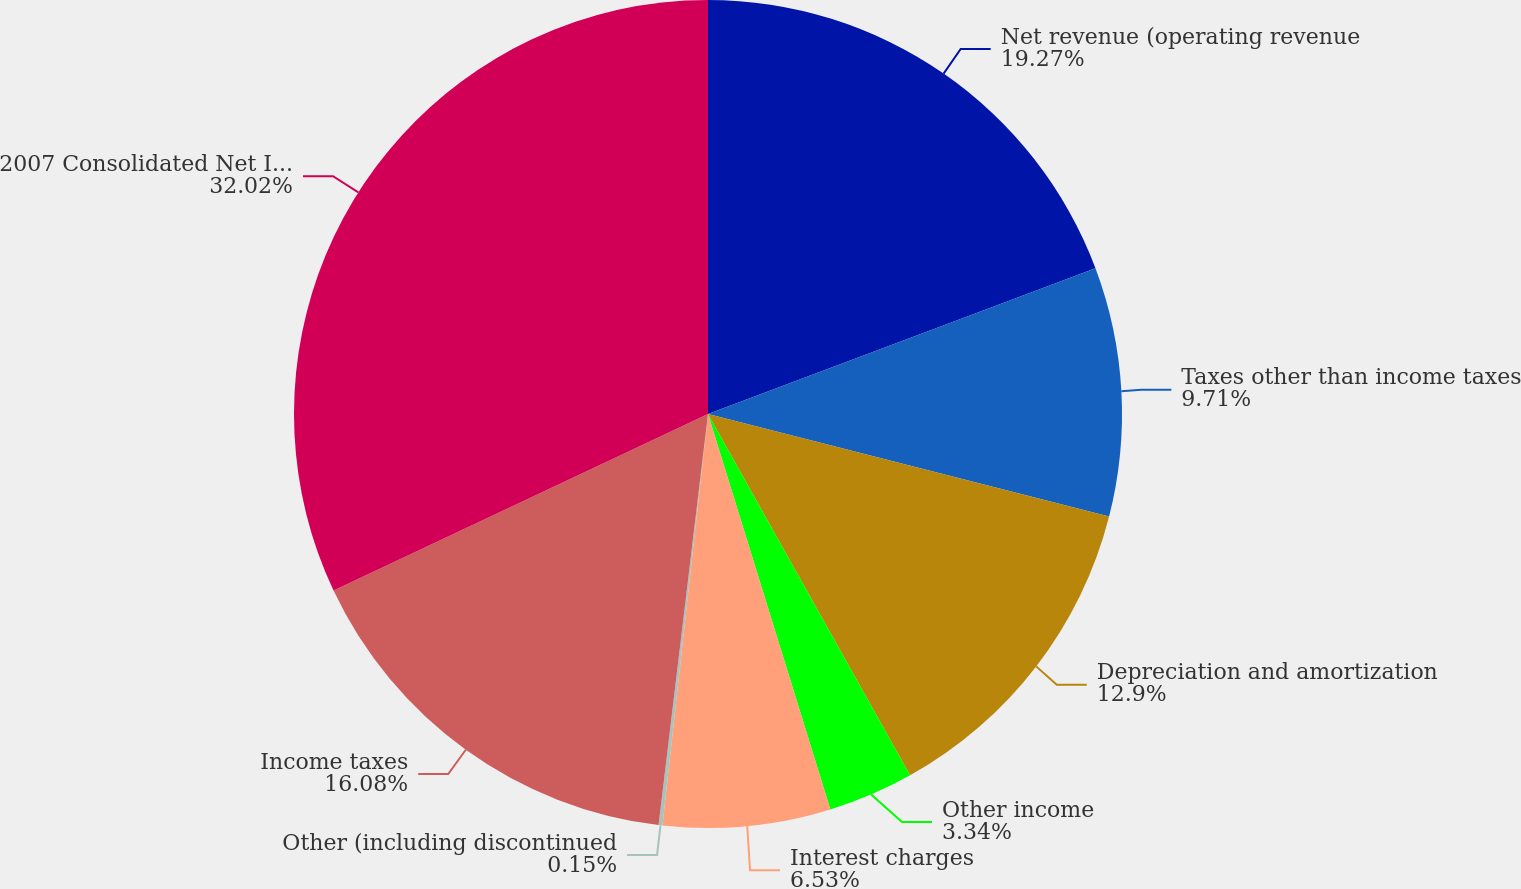Convert chart. <chart><loc_0><loc_0><loc_500><loc_500><pie_chart><fcel>Net revenue (operating revenue<fcel>Taxes other than income taxes<fcel>Depreciation and amortization<fcel>Other income<fcel>Interest charges<fcel>Other (including discontinued<fcel>Income taxes<fcel>2007 Consolidated Net Income<nl><fcel>19.27%<fcel>9.71%<fcel>12.9%<fcel>3.34%<fcel>6.53%<fcel>0.15%<fcel>16.08%<fcel>32.01%<nl></chart> 